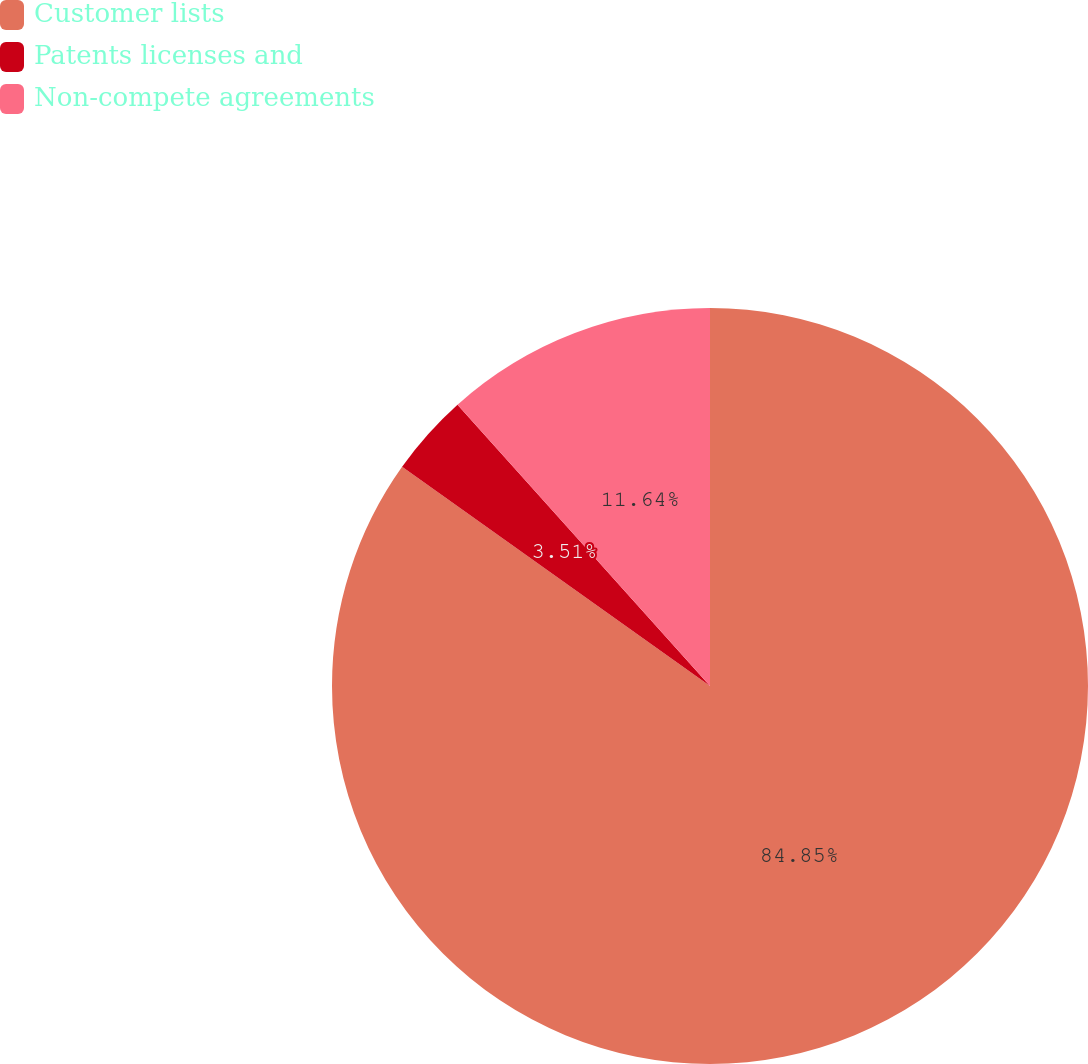<chart> <loc_0><loc_0><loc_500><loc_500><pie_chart><fcel>Customer lists<fcel>Patents licenses and<fcel>Non-compete agreements<nl><fcel>84.84%<fcel>3.51%<fcel>11.64%<nl></chart> 